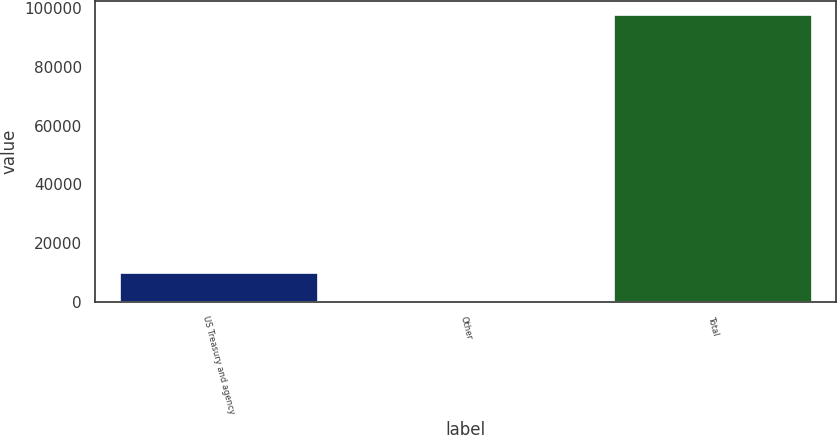Convert chart to OTSL. <chart><loc_0><loc_0><loc_500><loc_500><bar_chart><fcel>US Treasury and agency<fcel>Other<fcel>Total<nl><fcel>9802.7<fcel>56<fcel>97523<nl></chart> 